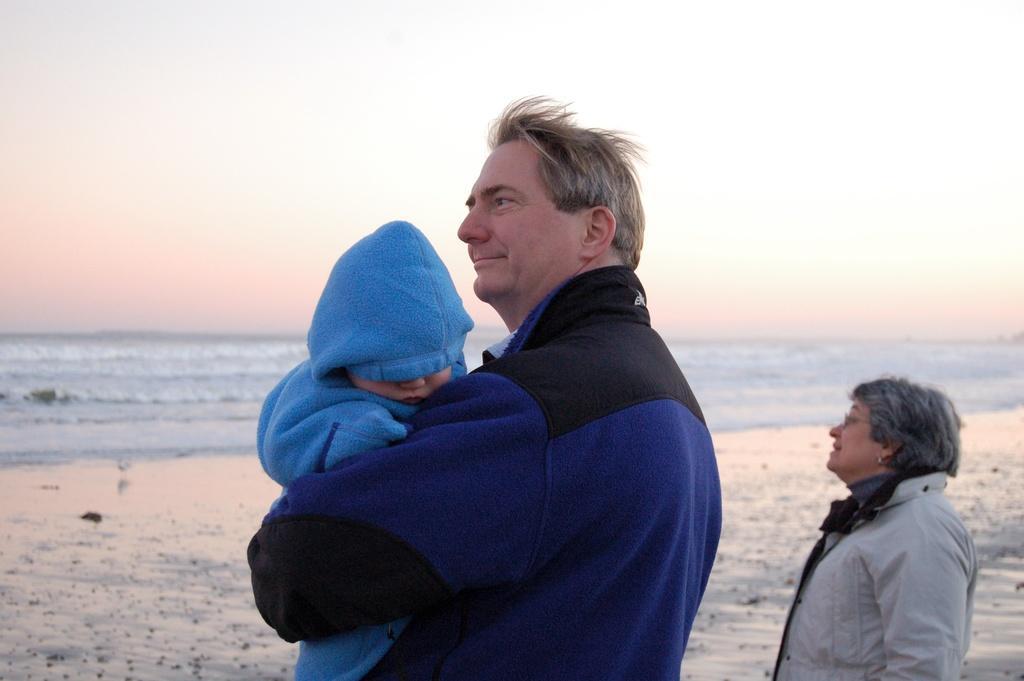In one or two sentences, can you explain what this image depicts? In the picture a man and a woman are standing on the ground. The man is carrying a child. The child is covered with blue color clothes. In the background I can see the sky and the water. 